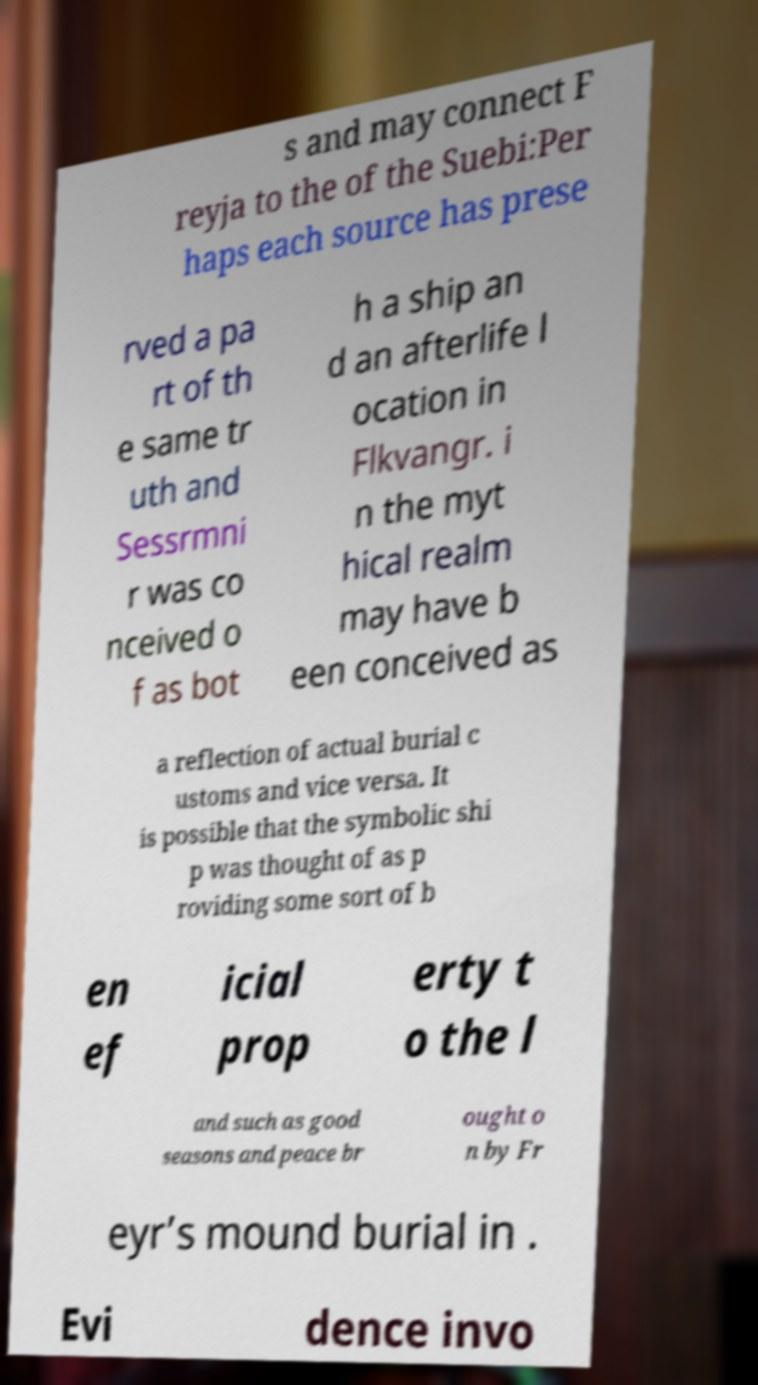Could you assist in decoding the text presented in this image and type it out clearly? s and may connect F reyja to the of the Suebi:Per haps each source has prese rved a pa rt of th e same tr uth and Sessrmni r was co nceived o f as bot h a ship an d an afterlife l ocation in Flkvangr. i n the myt hical realm may have b een conceived as a reflection of actual burial c ustoms and vice versa. It is possible that the symbolic shi p was thought of as p roviding some sort of b en ef icial prop erty t o the l and such as good seasons and peace br ought o n by Fr eyr’s mound burial in . Evi dence invo 